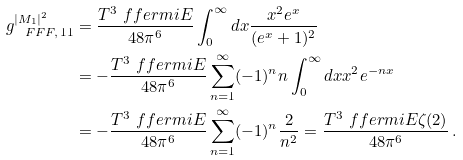Convert formula to latex. <formula><loc_0><loc_0><loc_500><loc_500>g _ { \ F F F , \, 1 1 } ^ { | M _ { 1 } | ^ { 2 } } & = \frac { T ^ { 3 } \ f f e r m i { E } } { 4 8 \pi ^ { 6 } } \int _ { 0 } ^ { \infty } d x \frac { x ^ { 2 } e ^ { x } } { ( e ^ { x } + 1 ) ^ { 2 } } \\ & = - \frac { T ^ { 3 } \ f f e r m i { E } } { 4 8 \pi ^ { 6 } } \sum _ { n = 1 } ^ { \infty } ( - 1 ) ^ { n } n \int _ { 0 } ^ { \infty } d x x ^ { 2 } e ^ { - n x } \\ & = - \frac { T ^ { 3 } \ f f e r m i { E } } { 4 8 \pi ^ { 6 } } \sum _ { n = 1 } ^ { \infty } ( - 1 ) ^ { n } \frac { 2 } { n ^ { 2 } } = \frac { T ^ { 3 } \ f f e r m i { E } \zeta ( 2 ) } { 4 8 \pi ^ { 6 } } \, .</formula> 